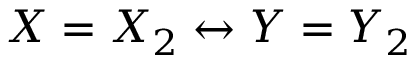<formula> <loc_0><loc_0><loc_500><loc_500>X = X _ { 2 } \leftrightarrow Y = Y _ { 2 }</formula> 